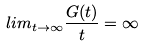<formula> <loc_0><loc_0><loc_500><loc_500>l i m _ { t \rightarrow \infty } \frac { G ( t ) } { t } = \infty</formula> 